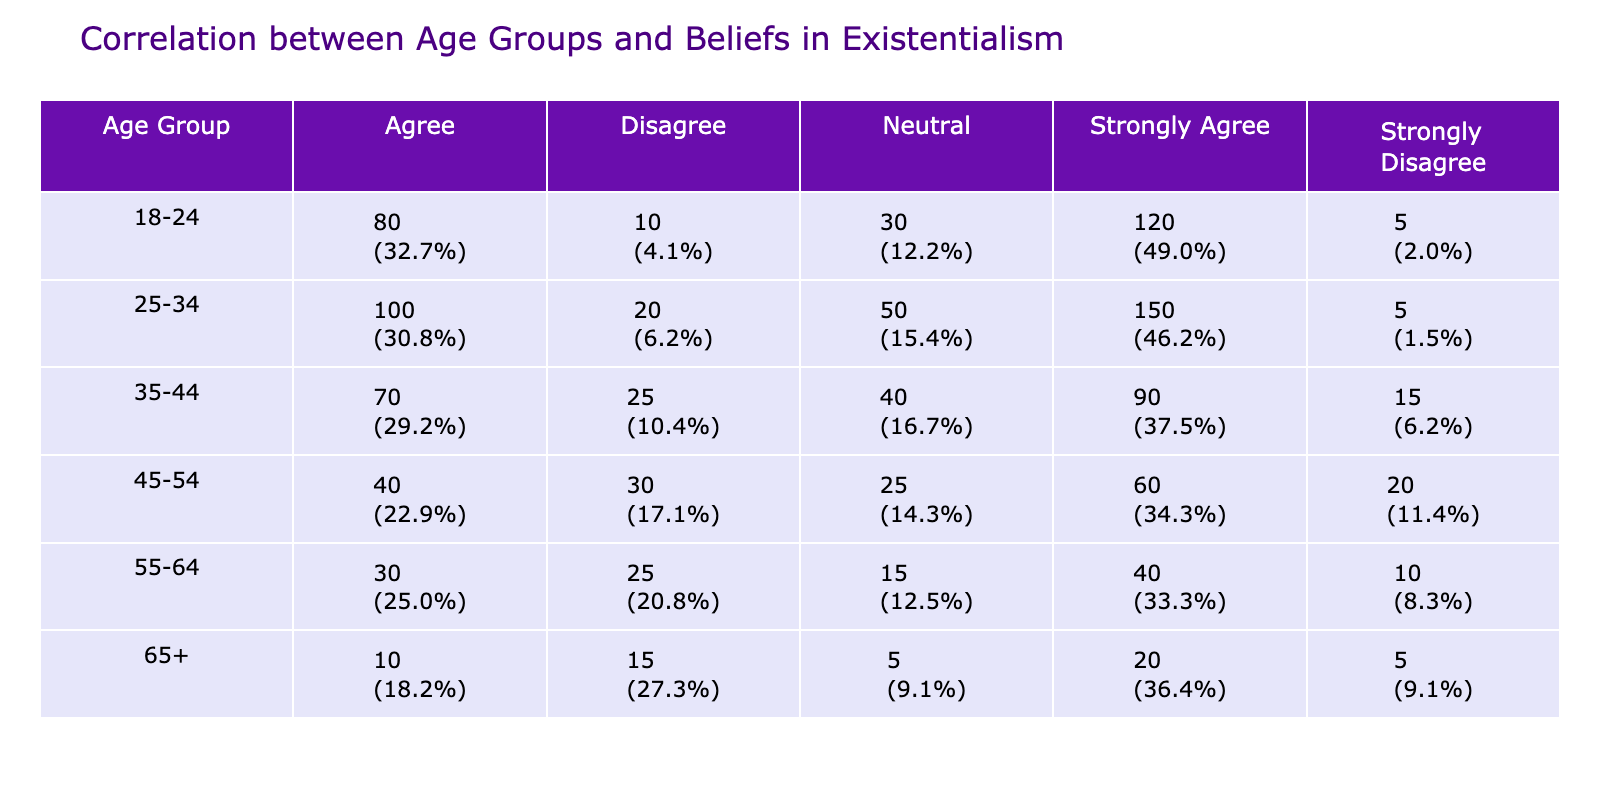What age group has the highest count of individuals who "Strongly Agree" with existentialism? The "Strongly Agree" category must be examined across all age groups. By looking at the table, the 25-34 age group shows a count of 150, which is higher than the other groups.
Answer: 25-34 What percentage of the 35-44 age group is "Strongly Agree"? The total count for the 35-44 age group is 90 (Strongly Agree) + 70 (Agree) + 40 (Neutral) + 25 (Disagree) + 15 (Strongly Disagree) = 240. The percentage for "Strongly Agree" is (90/240) * 100 = 37.5%.
Answer: 37.5% Is the "Agree" count for the 18-24 age group greater than the total "Disagree" count across all age groups? The "Agree" count for 18-24 is 80. To answer, we need to find the "Disagree" counts for all age groups: 10 (18-24) + 20 (25-34) + 25 (35-44) + 30 (45-54) + 15 (55-64) + 15 (65+) = 110. Since 80 is less than 110, the statement is false.
Answer: No What is the total count of individuals who "Neutral" across all age groups? We will sum the "Neutral" counts: 30 (18-24) + 50 (25-34) + 40 (35-44) + 25 (45-54) + 15 (55-64) + 5 (65+) = 165.
Answer: 165 Which age group has the least count of "Strongly Disagree"? The "Strongly Disagree" counts need to be compared: 5 (18-24), 5 (25-34), 15 (35-44), 20 (45-54), 10 (55-64), and 5 (65+). The counts for the 18-24, 25-34, and 65+ age groups are tied at 5, which is the least.
Answer: 18-24 and 25-34 and 65+ What is the difference in "Agree" counts between the 25-34 and 45-54 age groups? The counts for "Agree" are 100 (25-34) and 40 (45-54). The difference is calculated as 100 - 40 = 60.
Answer: 60 Is the total count of individuals who "Disagree" across all age groups more than 100? We sum the "Disagree" counts: 10 (18-24) + 20 (25-34) + 25 (35-44) + 30 (45-54) + 25 (55-64) + 15 (65+) = 125. Since 125 is greater than 100, the statement is true.
Answer: Yes Which belief category has the highest total count when combining all age groups? Adding the counts of each belief category: Strongly Agree = 150 + 120 + 90 + 60 + 40 + 20 = 480, Agree = 100 + 80 + 70 + 40 + 30 + 10 = 430, Neutral = 30 + 50 + 40 + 25 + 15 + 5 = 165, Disagree = 10 + 20 + 25 + 30 + 25 + 15 = 135, Strongly Disagree = 5 + 5 + 15 + 20 + 10 + 5 = 60. Strongly Agree has the highest total count of 480.
Answer: Strongly Agree 